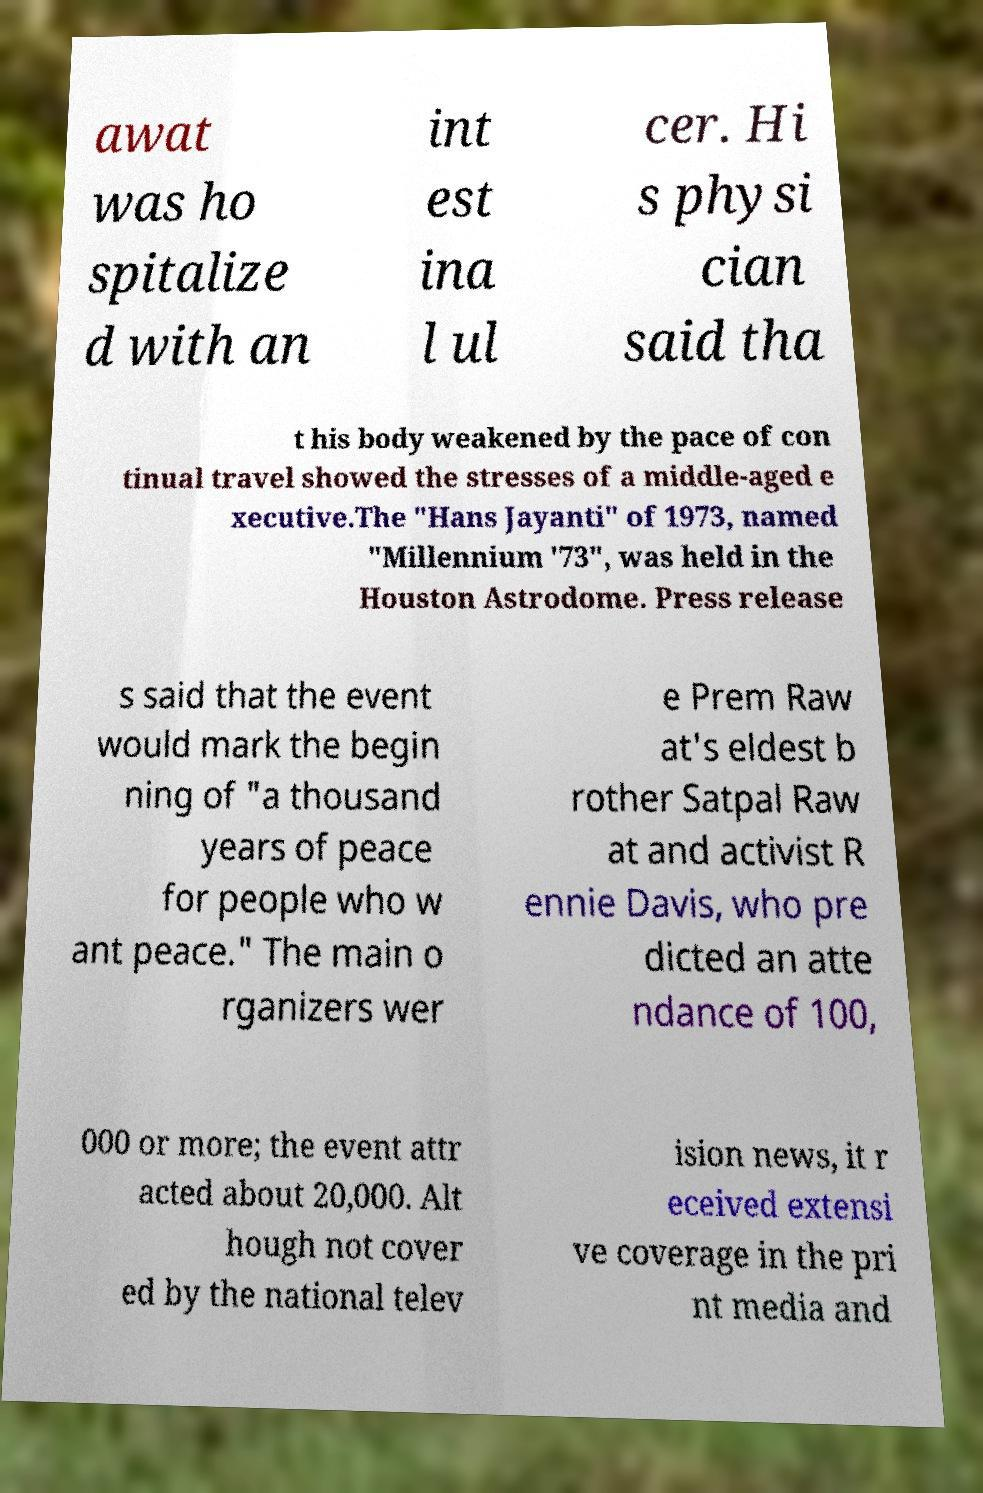Can you accurately transcribe the text from the provided image for me? awat was ho spitalize d with an int est ina l ul cer. Hi s physi cian said tha t his body weakened by the pace of con tinual travel showed the stresses of a middle-aged e xecutive.The "Hans Jayanti" of 1973, named "Millennium '73", was held in the Houston Astrodome. Press release s said that the event would mark the begin ning of "a thousand years of peace for people who w ant peace." The main o rganizers wer e Prem Raw at's eldest b rother Satpal Raw at and activist R ennie Davis, who pre dicted an atte ndance of 100, 000 or more; the event attr acted about 20,000. Alt hough not cover ed by the national telev ision news, it r eceived extensi ve coverage in the pri nt media and 